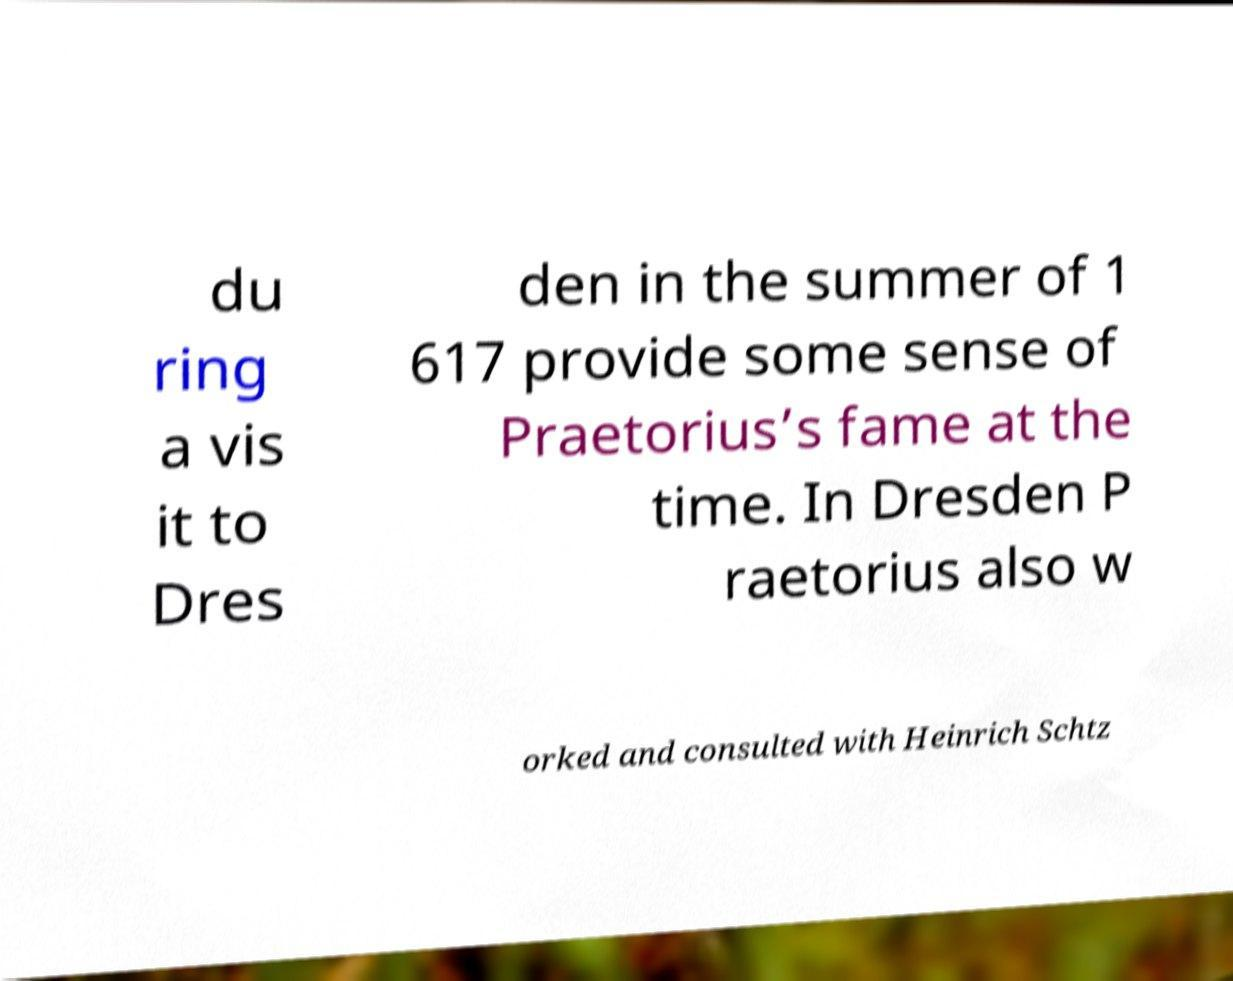There's text embedded in this image that I need extracted. Can you transcribe it verbatim? du ring a vis it to Dres den in the summer of 1 617 provide some sense of Praetorius’s fame at the time. In Dresden P raetorius also w orked and consulted with Heinrich Schtz 